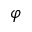<formula> <loc_0><loc_0><loc_500><loc_500>\varphi</formula> 